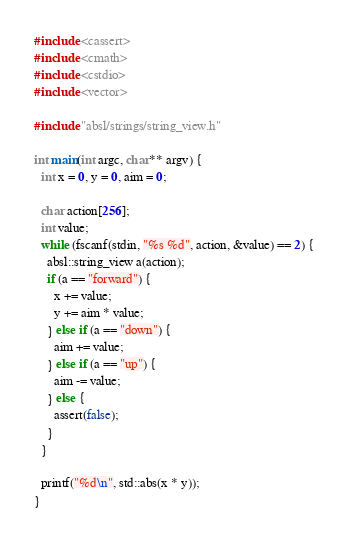<code> <loc_0><loc_0><loc_500><loc_500><_C++_>#include <cassert>
#include <cmath>
#include <cstdio>
#include <vector>

#include "absl/strings/string_view.h"

int main(int argc, char** argv) {
  int x = 0, y = 0, aim = 0;

  char action[256];
  int value;
  while (fscanf(stdin, "%s %d", action, &value) == 2) {
    absl::string_view a(action);
    if (a == "forward") {
      x += value;
      y += aim * value;
    } else if (a == "down") {
      aim += value;
    } else if (a == "up") {
      aim -= value;
    } else {
      assert(false);
    }
  }

  printf("%d\n", std::abs(x * y));
}
</code> 